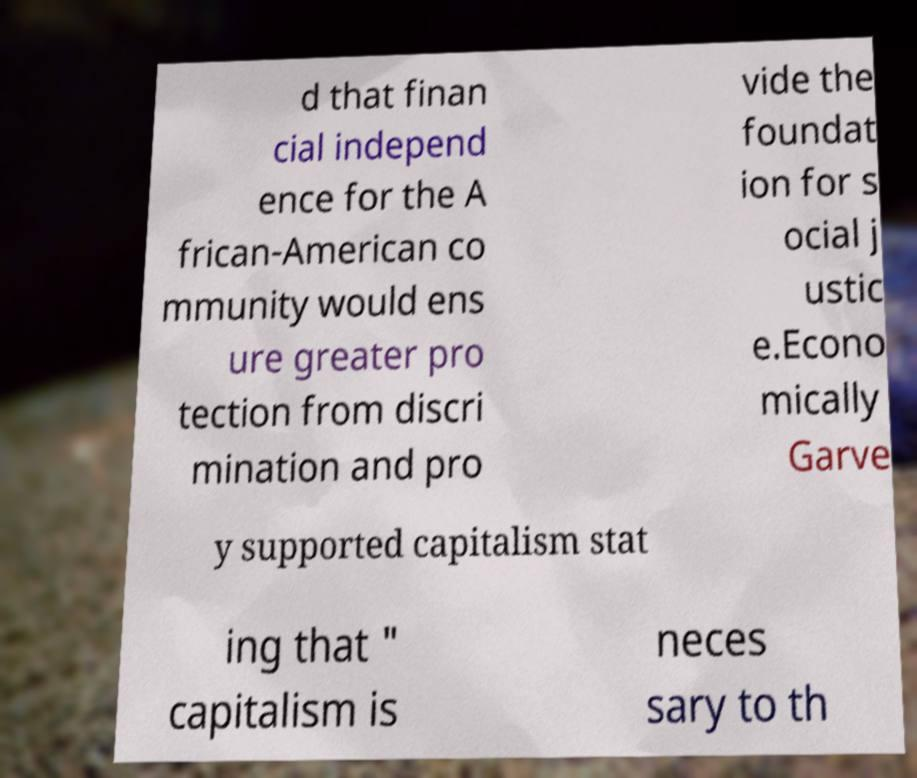Can you read and provide the text displayed in the image?This photo seems to have some interesting text. Can you extract and type it out for me? d that finan cial independ ence for the A frican-American co mmunity would ens ure greater pro tection from discri mination and pro vide the foundat ion for s ocial j ustic e.Econo mically Garve y supported capitalism stat ing that " capitalism is neces sary to th 